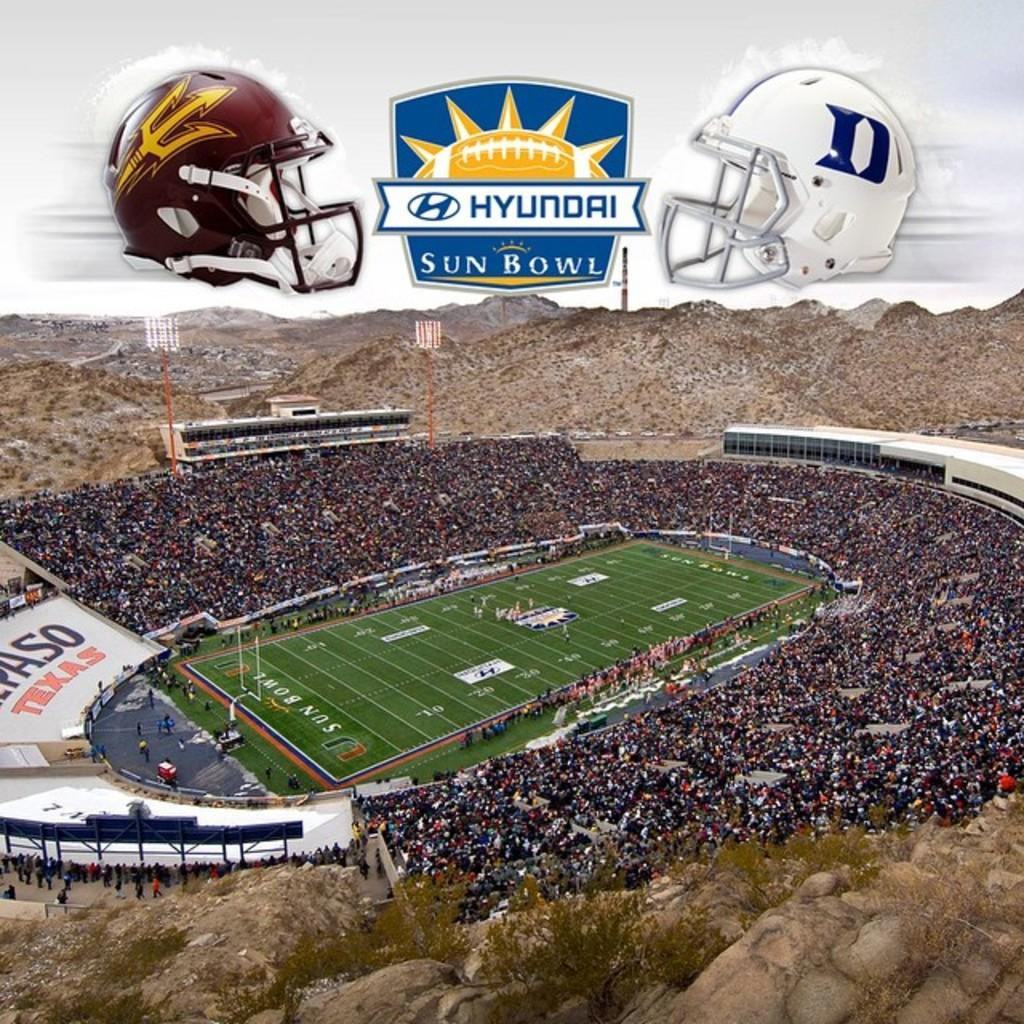What type of location is depicted in the image? The image shows an aerial view of a stadium. What additional feature can be seen inside the stadium? There is a playground inside the stadium. Who might be present at the stadium? There are people (audience) around the stadium. What can be seen in the distance behind the stadium? There are hills visible in the background. How many frogs are sitting on the dad's bead in the image? There is no dad, frogs, or bead present in the image. 